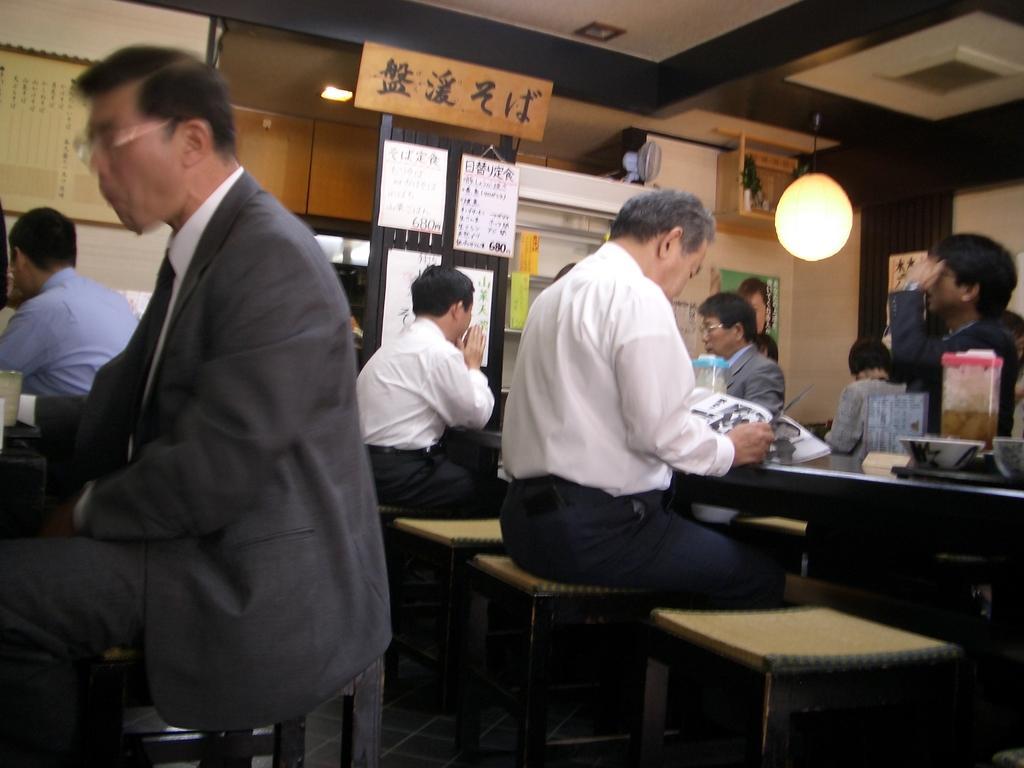Please provide a concise description of this image. Some men are sitting on stools at a tables. There are located in a Chinese restaurant. There are some jars and bowls on the table. There are boards on the wall written in Chinese language. 